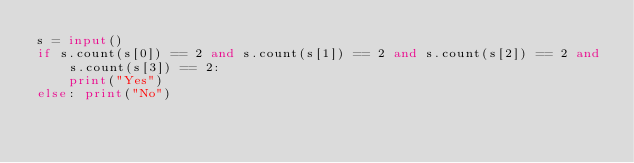<code> <loc_0><loc_0><loc_500><loc_500><_Python_>s = input()
if s.count(s[0]) == 2 and s.count(s[1]) == 2 and s.count(s[2]) == 2 and s.count(s[3]) == 2:
    print("Yes")
else: print("No")</code> 